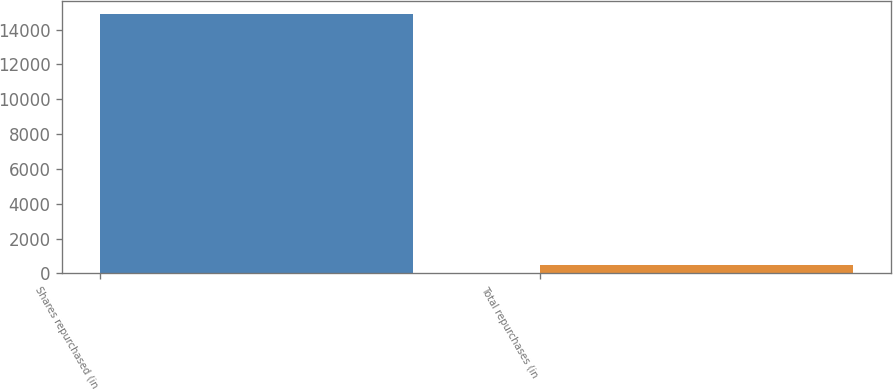<chart> <loc_0><loc_0><loc_500><loc_500><bar_chart><fcel>Shares repurchased (in<fcel>Total repurchases (in<nl><fcel>14920<fcel>501<nl></chart> 